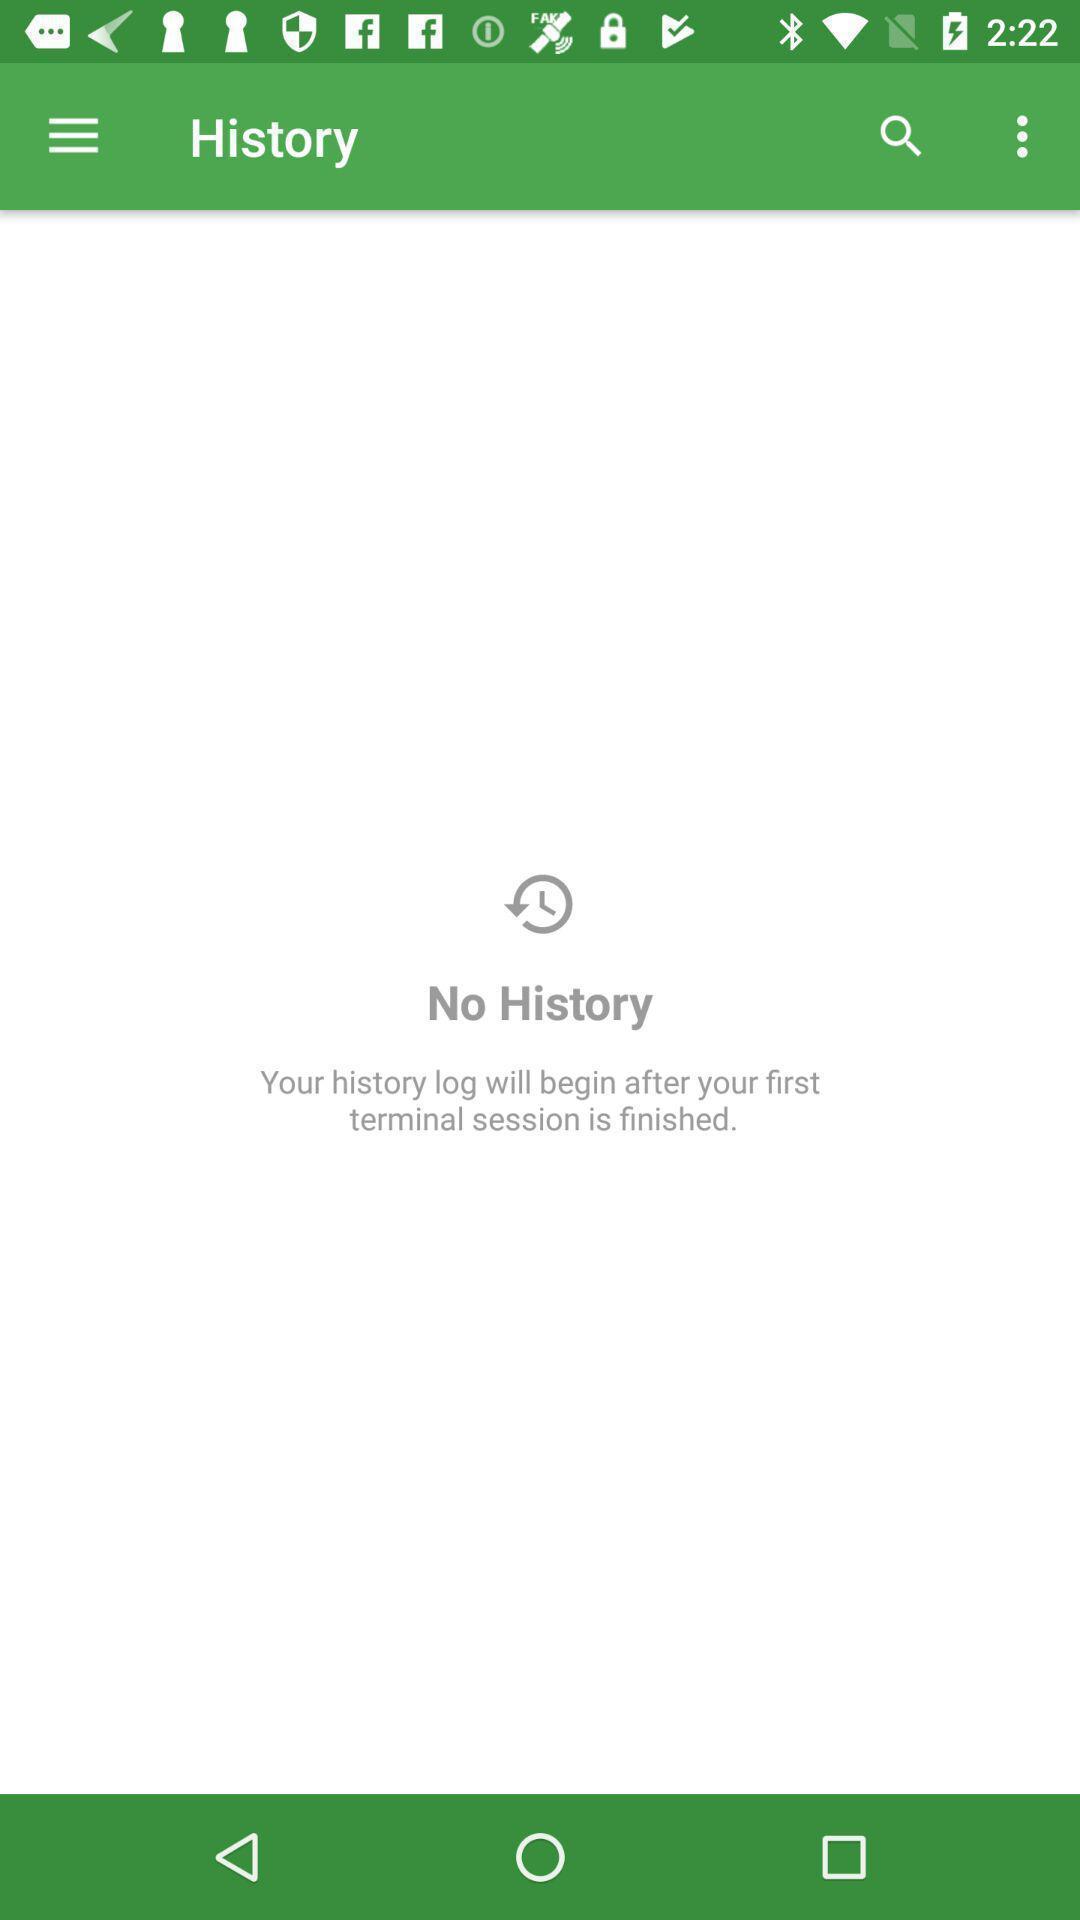Tell me about the visual elements in this screen capture. Page displaying no history in app. 